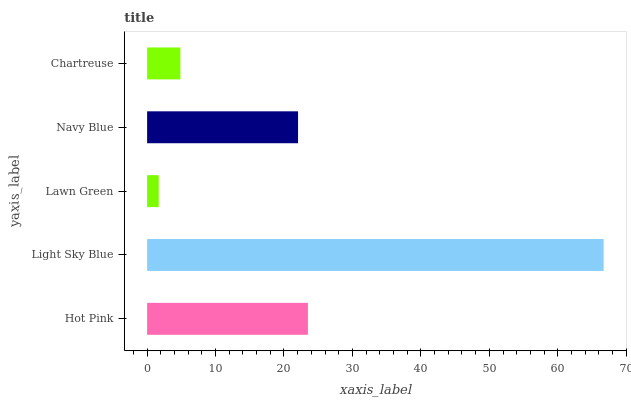Is Lawn Green the minimum?
Answer yes or no. Yes. Is Light Sky Blue the maximum?
Answer yes or no. Yes. Is Light Sky Blue the minimum?
Answer yes or no. No. Is Lawn Green the maximum?
Answer yes or no. No. Is Light Sky Blue greater than Lawn Green?
Answer yes or no. Yes. Is Lawn Green less than Light Sky Blue?
Answer yes or no. Yes. Is Lawn Green greater than Light Sky Blue?
Answer yes or no. No. Is Light Sky Blue less than Lawn Green?
Answer yes or no. No. Is Navy Blue the high median?
Answer yes or no. Yes. Is Navy Blue the low median?
Answer yes or no. Yes. Is Light Sky Blue the high median?
Answer yes or no. No. Is Chartreuse the low median?
Answer yes or no. No. 